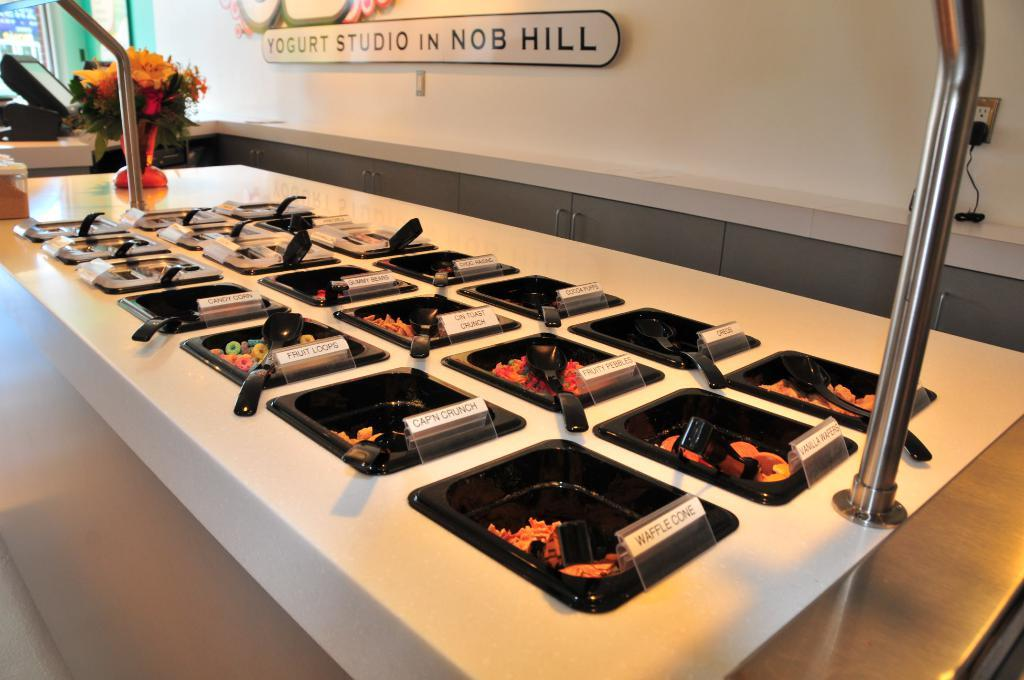Provide a one-sentence caption for the provided image. A buffet spread at Yogurt Studio in Nob Hill. 